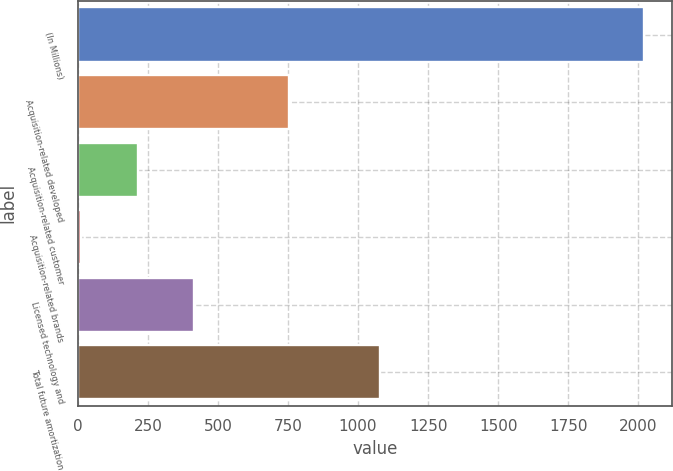Convert chart. <chart><loc_0><loc_0><loc_500><loc_500><bar_chart><fcel>(In Millions)<fcel>Acquisition-related developed<fcel>Acquisition-related customer<fcel>Acquisition-related brands<fcel>Licensed technology and<fcel>Total future amortization<nl><fcel>2020<fcel>753<fcel>213.7<fcel>13<fcel>414.4<fcel>1079<nl></chart> 